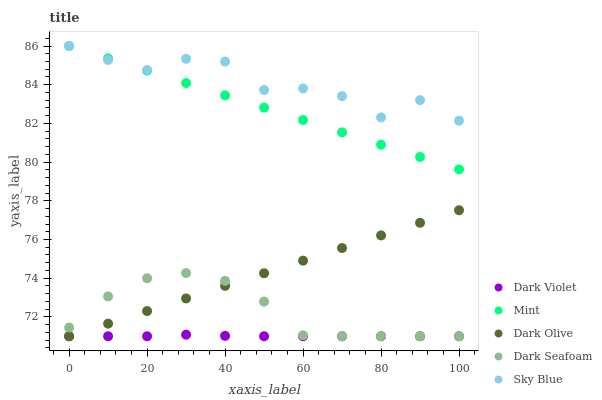Does Dark Violet have the minimum area under the curve?
Answer yes or no. Yes. Does Sky Blue have the maximum area under the curve?
Answer yes or no. Yes. Does Dark Seafoam have the minimum area under the curve?
Answer yes or no. No. Does Dark Seafoam have the maximum area under the curve?
Answer yes or no. No. Is Dark Olive the smoothest?
Answer yes or no. Yes. Is Sky Blue the roughest?
Answer yes or no. Yes. Is Dark Seafoam the smoothest?
Answer yes or no. No. Is Dark Seafoam the roughest?
Answer yes or no. No. Does Dark Seafoam have the lowest value?
Answer yes or no. Yes. Does Mint have the lowest value?
Answer yes or no. No. Does Mint have the highest value?
Answer yes or no. Yes. Does Dark Seafoam have the highest value?
Answer yes or no. No. Is Dark Seafoam less than Mint?
Answer yes or no. Yes. Is Sky Blue greater than Dark Violet?
Answer yes or no. Yes. Does Dark Seafoam intersect Dark Violet?
Answer yes or no. Yes. Is Dark Seafoam less than Dark Violet?
Answer yes or no. No. Is Dark Seafoam greater than Dark Violet?
Answer yes or no. No. Does Dark Seafoam intersect Mint?
Answer yes or no. No. 